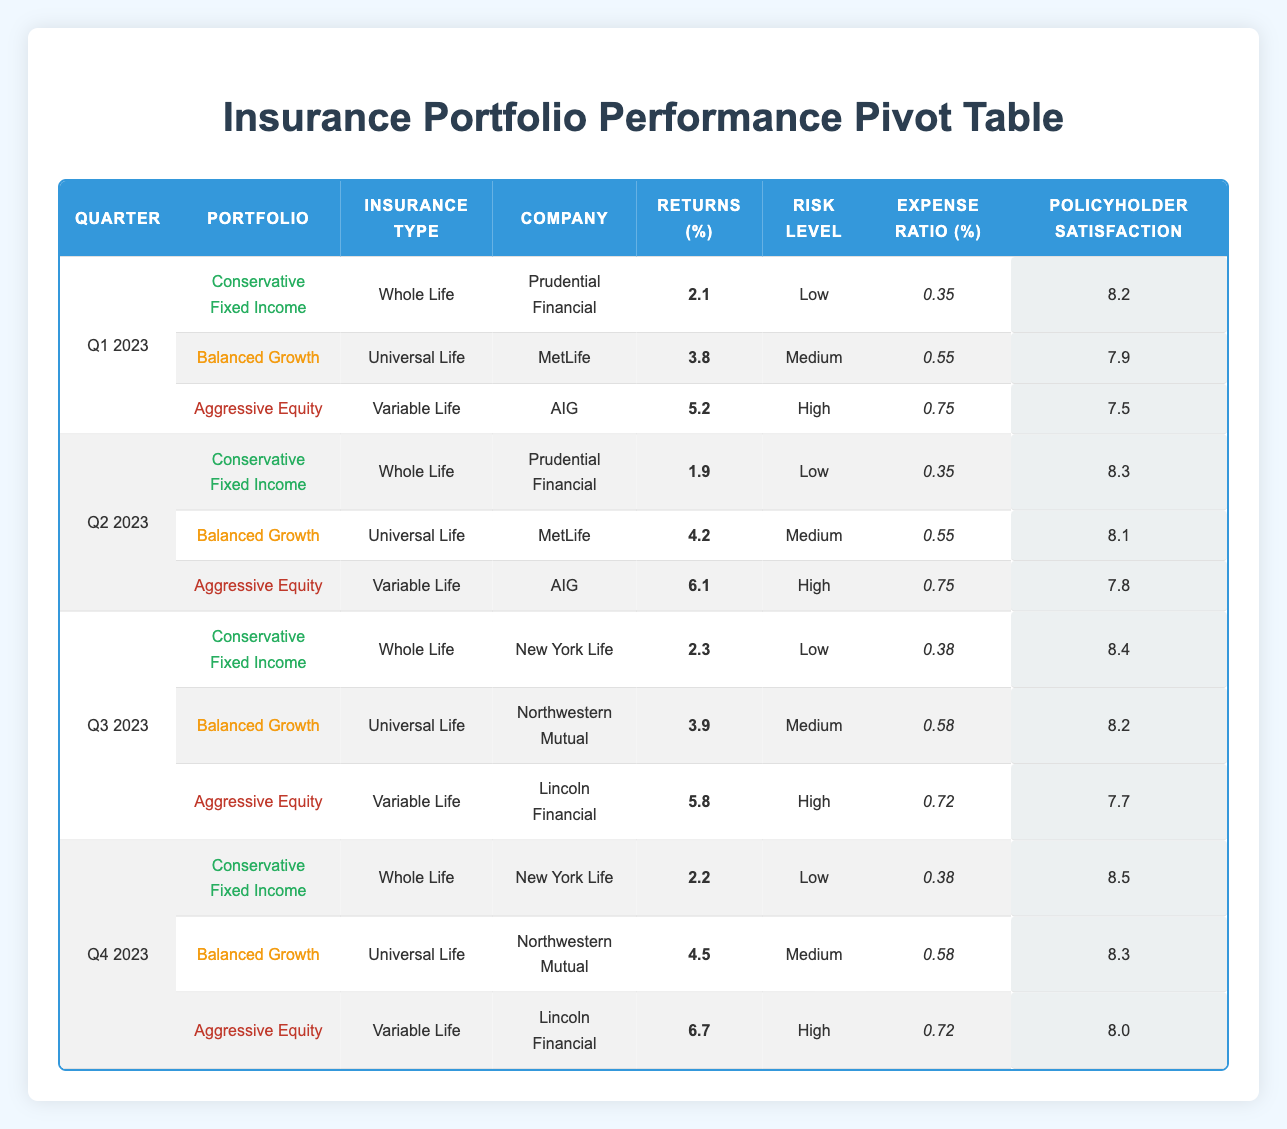What is the return percentage for the Aggressive Equity portfolio in Q2 2023? In Q2 2023, the Aggressive Equity portfolio has a return percentage listed in the table. We locate the row that corresponds to Q2 2023 and find Aggressive Equity, which shows returns as 6.1%.
Answer: 6.1 Which company offered the Conservative Fixed Income portfolio in Q3 2023? By looking at Q3 2023 in the table, we find the row for the Conservative Fixed Income portfolio. It shows that the company providing this portfolio is New York Life.
Answer: New York Life Is the Policyholder Satisfaction for Balanced Growth higher in Q1 2023 or Q2 2023? To answer this, we check the Policyholder Satisfaction values for the Balanced Growth portfolio in both Q1 and Q2 2023. In Q1 2023, the satisfaction is 7.9, and in Q2 2023, it is 8.1. Since 8.1 is greater than 7.9, the satisfaction in Q2 is higher.
Answer: Q2 2023 What is the average Expense Ratio of the Aggressive Equity portfolio across all quarters? We need to extract the Expense Ratio for the Aggressive Equity portfolio from each quarter. The values are 0.75 (Q1), 0.75 (Q2), 0.72 (Q3), and 0.72 (Q4). To calculate the average, we sum these values (0.75 + 0.75 + 0.72 + 0.72 = 3.04) and divide by the number of quarters (4). The average Expense Ratio is 3.04 / 4 = 0.76.
Answer: 0.76 Did any of the portfolios have a Risk Level classified as High in Q3 2023? In Q3 2023, we check the Risk Level for each portfolio listed. The Aggressive Equity portfolio is listed with a Risk Level of High, confirming that at least one portfolio did have a High Risk Level in that quarter.
Answer: Yes What is the difference in Returns between the Balanced Growth and Aggressive Equity portfolios in Q4 2023? First, we locate the Returns for both portfolios in Q4 2023. The Balanced Growth portfolio shows returns of 4.5%, and the Aggressive Equity portfolio shows returns of 6.7%. To find the difference, we subtract the return of Balanced Growth from Aggressive Equity (6.7 - 4.5 = 2.2).
Answer: 2.2 Which portfolio has the highest Policyholder Satisfaction in Q1 2023? In Q1 2023, we look at the Policyholder Satisfaction values from the table. The values are 8.2 for Conservative Fixed Income, 7.9 for Balanced Growth, and 7.5 for Aggressive Equity. The highest among them is 8.2 from the Conservative Fixed Income portfolio.
Answer: Conservative Fixed Income In which quarter did the Conservative Fixed Income portfolio have the lowest Return percentage? To find this, we review the Returns for the Conservative Fixed Income across all quarters: 2.1% (Q1), 1.9% (Q2), 2.3% (Q3), and 2.2% (Q4). The lowest value is 1.9%, which occurs in Q2 2023.
Answer: Q2 2023 